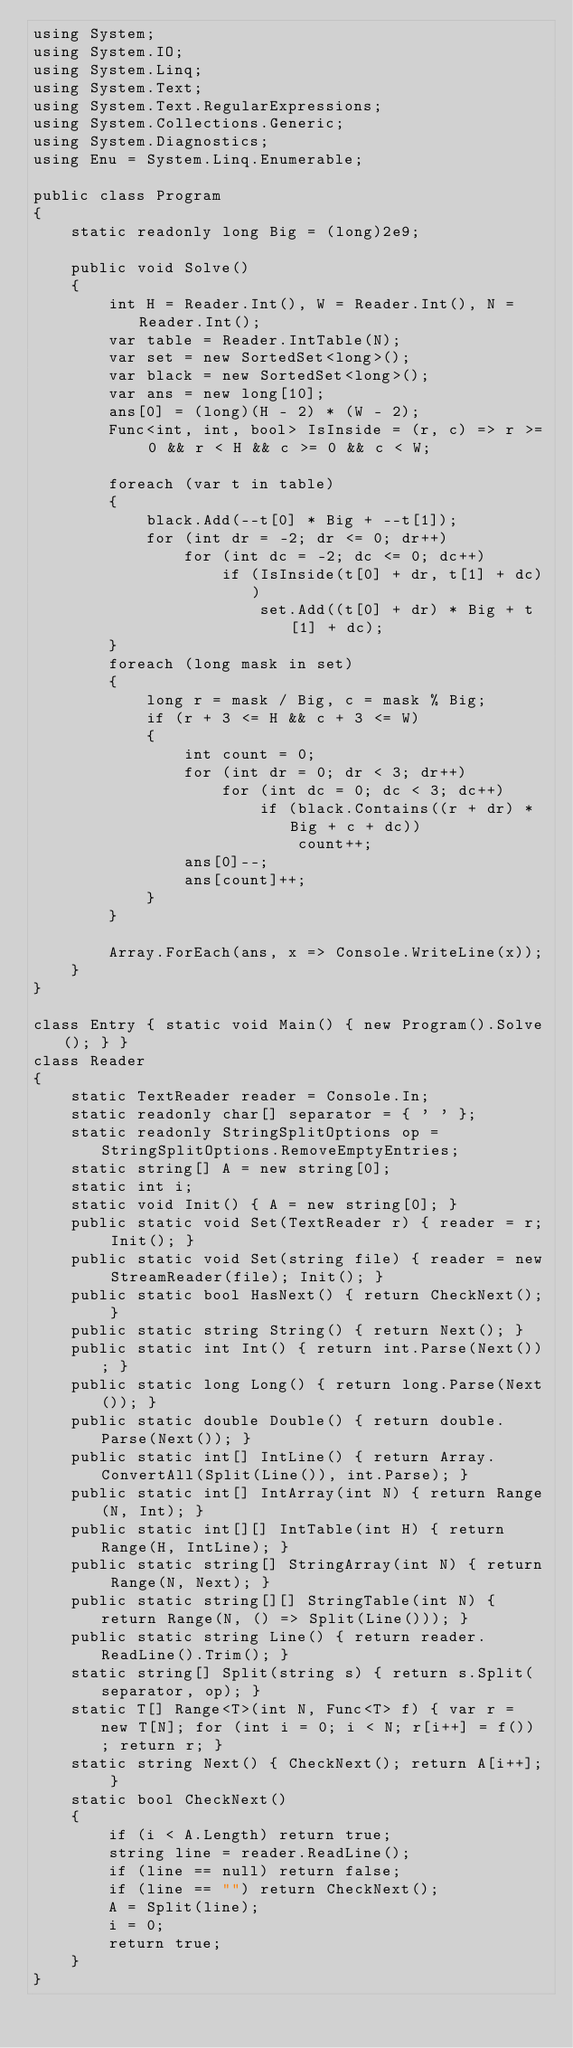Convert code to text. <code><loc_0><loc_0><loc_500><loc_500><_C#_>using System;
using System.IO;
using System.Linq;
using System.Text;
using System.Text.RegularExpressions;
using System.Collections.Generic;
using System.Diagnostics;
using Enu = System.Linq.Enumerable;

public class Program
{
    static readonly long Big = (long)2e9;

    public void Solve()
    {
        int H = Reader.Int(), W = Reader.Int(), N = Reader.Int();
        var table = Reader.IntTable(N);
        var set = new SortedSet<long>();
        var black = new SortedSet<long>();
        var ans = new long[10];
        ans[0] = (long)(H - 2) * (W - 2);
        Func<int, int, bool> IsInside = (r, c) => r >= 0 && r < H && c >= 0 && c < W;

        foreach (var t in table)
        {
            black.Add(--t[0] * Big + --t[1]);
            for (int dr = -2; dr <= 0; dr++)
                for (int dc = -2; dc <= 0; dc++)
                    if (IsInside(t[0] + dr, t[1] + dc))
                        set.Add((t[0] + dr) * Big + t[1] + dc);
        }
        foreach (long mask in set)
        {
            long r = mask / Big, c = mask % Big;
            if (r + 3 <= H && c + 3 <= W)
            {
                int count = 0;
                for (int dr = 0; dr < 3; dr++)
                    for (int dc = 0; dc < 3; dc++)
                        if (black.Contains((r + dr) * Big + c + dc))
                            count++;
                ans[0]--;
                ans[count]++;
            }
        }

        Array.ForEach(ans, x => Console.WriteLine(x));
    }
}

class Entry { static void Main() { new Program().Solve(); } }
class Reader
{
    static TextReader reader = Console.In;
    static readonly char[] separator = { ' ' };
    static readonly StringSplitOptions op = StringSplitOptions.RemoveEmptyEntries;
    static string[] A = new string[0];
    static int i;
    static void Init() { A = new string[0]; }
    public static void Set(TextReader r) { reader = r; Init(); }
    public static void Set(string file) { reader = new StreamReader(file); Init(); }
    public static bool HasNext() { return CheckNext(); }
    public static string String() { return Next(); }
    public static int Int() { return int.Parse(Next()); }
    public static long Long() { return long.Parse(Next()); }
    public static double Double() { return double.Parse(Next()); }
    public static int[] IntLine() { return Array.ConvertAll(Split(Line()), int.Parse); }
    public static int[] IntArray(int N) { return Range(N, Int); }
    public static int[][] IntTable(int H) { return Range(H, IntLine); }
    public static string[] StringArray(int N) { return Range(N, Next); }
    public static string[][] StringTable(int N) { return Range(N, () => Split(Line())); }
    public static string Line() { return reader.ReadLine().Trim(); }
    static string[] Split(string s) { return s.Split(separator, op); }
    static T[] Range<T>(int N, Func<T> f) { var r = new T[N]; for (int i = 0; i < N; r[i++] = f()) ; return r; }
    static string Next() { CheckNext(); return A[i++]; }
    static bool CheckNext()
    {
        if (i < A.Length) return true;
        string line = reader.ReadLine();
        if (line == null) return false;
        if (line == "") return CheckNext();
        A = Split(line);
        i = 0;
        return true;
    }
}</code> 